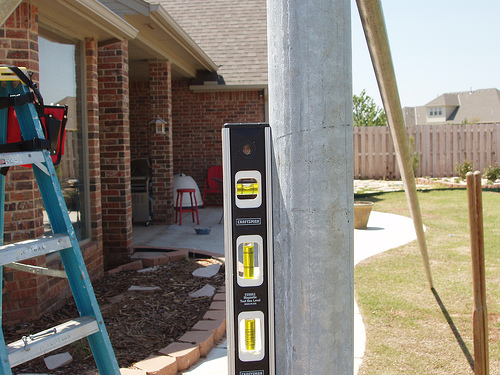<image>
Can you confirm if the window is behind the level? Yes. From this viewpoint, the window is positioned behind the level, with the level partially or fully occluding the window. 